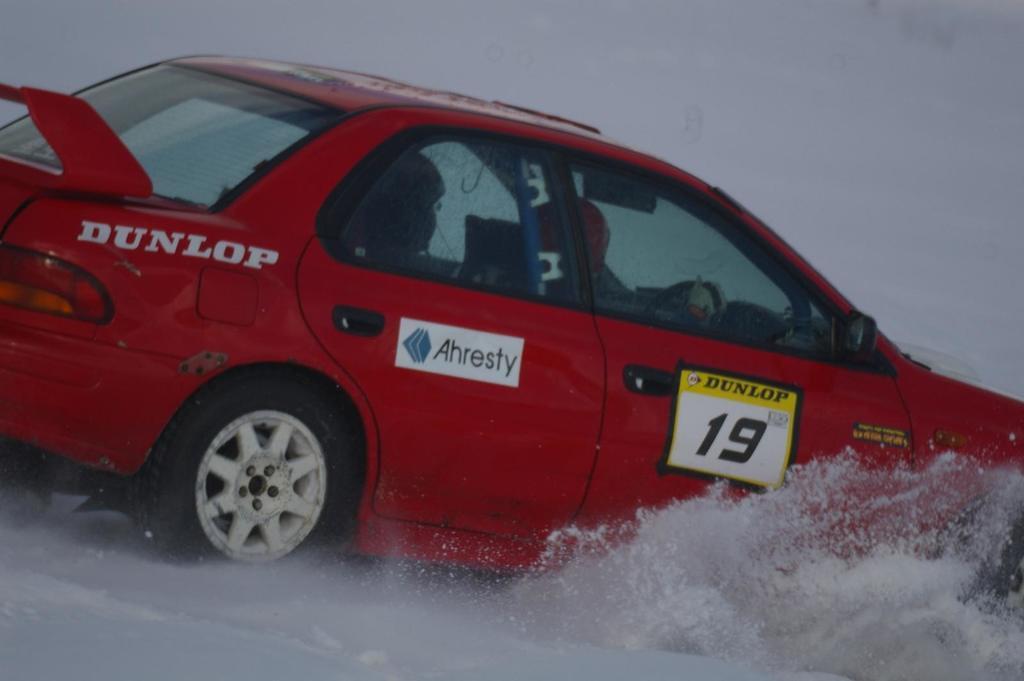Describe this image in one or two sentences. In this picture there is a person driving a red color car on the snow. 